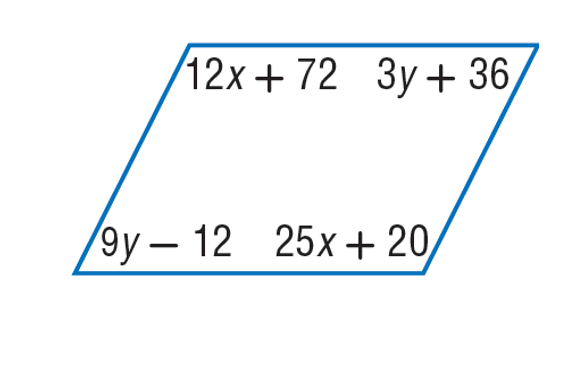Answer the mathemtical geometry problem and directly provide the correct option letter.
Question: Find x so that the quadrilateral is a parallelogram.
Choices: A: 4 B: 12 C: 25 D: 45 A 